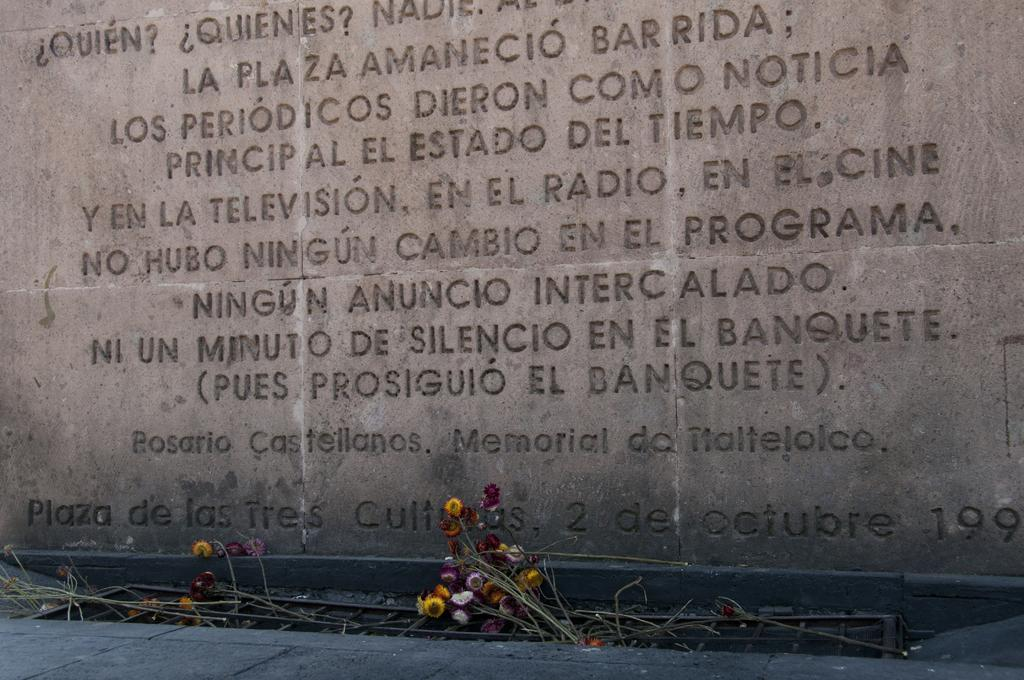What is present on the wall in the image? There is script on the wall in the image. What can be seen at the bottom of the image? There are flowers and wooden sticks at the bottom of the image. What type of birthday celebration is depicted in the image? There is no indication of a birthday celebration in the image. Are there any slaves present in the image? There is no mention of slaves or any related context in the image. 